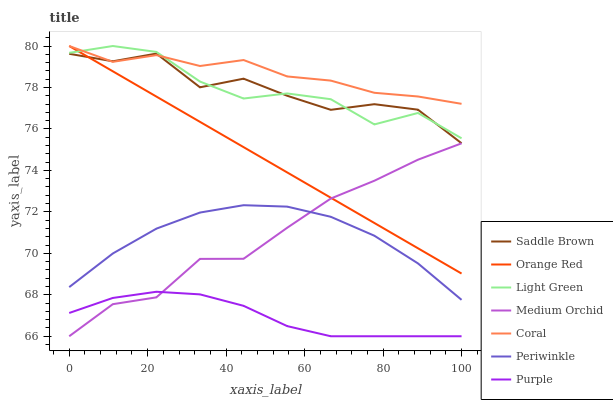Does Purple have the minimum area under the curve?
Answer yes or no. Yes. Does Coral have the maximum area under the curve?
Answer yes or no. Yes. Does Medium Orchid have the minimum area under the curve?
Answer yes or no. No. Does Medium Orchid have the maximum area under the curve?
Answer yes or no. No. Is Orange Red the smoothest?
Answer yes or no. Yes. Is Saddle Brown the roughest?
Answer yes or no. Yes. Is Coral the smoothest?
Answer yes or no. No. Is Coral the roughest?
Answer yes or no. No. Does Purple have the lowest value?
Answer yes or no. Yes. Does Coral have the lowest value?
Answer yes or no. No. Does Light Green have the highest value?
Answer yes or no. Yes. Does Medium Orchid have the highest value?
Answer yes or no. No. Is Medium Orchid less than Coral?
Answer yes or no. Yes. Is Light Green greater than Purple?
Answer yes or no. Yes. Does Saddle Brown intersect Coral?
Answer yes or no. Yes. Is Saddle Brown less than Coral?
Answer yes or no. No. Is Saddle Brown greater than Coral?
Answer yes or no. No. Does Medium Orchid intersect Coral?
Answer yes or no. No. 